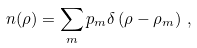<formula> <loc_0><loc_0><loc_500><loc_500>n ( \rho ) = \sum _ { m } p _ { m } \delta \left ( \rho - \rho _ { m } \right ) \, ,</formula> 